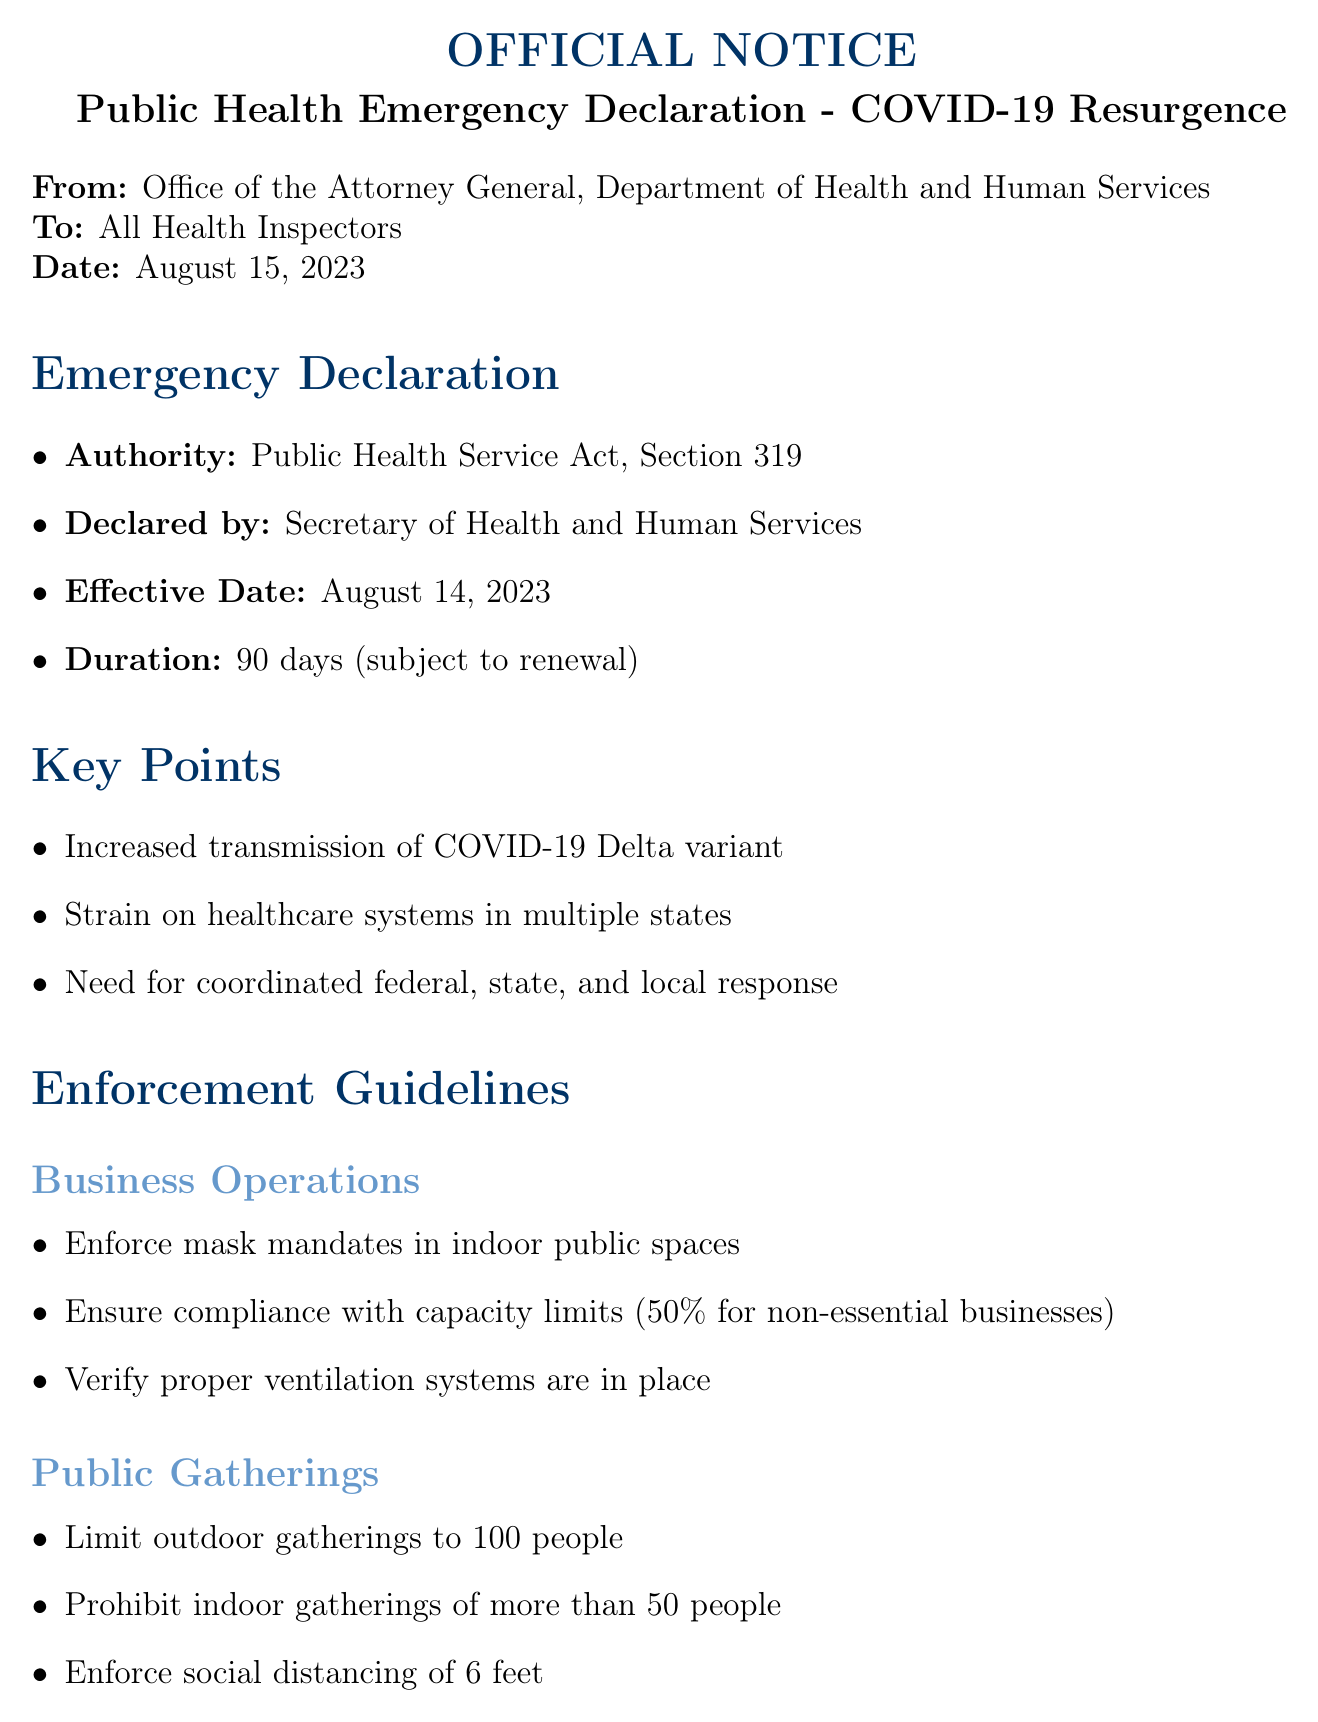What is the subject of the notice? The subject is explicitly stated in the header of the document, which outlines the main focus of the notice.
Answer: Official Notice: Public Health Emergency Declaration - COVID-19 Resurgence Who declared the emergency? The document specifies the individual responsible for declaring the emergency, citing their official position.
Answer: Secretary of Health and Human Services What is the effective date of the declaration? The effective date is listed in the emergency declaration section, which indicates when the declaration takes effect.
Answer: August 14, 2023 What area requires compliance with capacity limits? The enforcement guidelines section outlines specific areas and the corresponding actions that must be taken, indicating where compliance is necessary.
Answer: Business Operations How long is the duration of the emergency declaration? The document provides information in the emergency declaration section regarding how long the declaration is set to last.
Answer: 90 days (subject to renewal) What is the maximum number of people allowed at outdoor gatherings? The document specifically states the limit for outdoor gatherings within the enforcement guidelines.
Answer: 100 people What should be prioritized in healthcare facilities? The enforcement guidelines highlight specific actions for healthcare facilities, indicating what is to be prioritized.
Answer: COVID-19 testing and treatment What are the potential consequences for non-compliance? The legal considerations section discusses the implications that may arise if guidelines are not followed, clarifying the repercussions.
Answer: Civil penalties Who can be contacted for legal support? The contact information section specifies whom to reach out to for legal support, providing a designated team or contact number.
Answer: Emergency Response Legal Team: 1-800-555-1234 